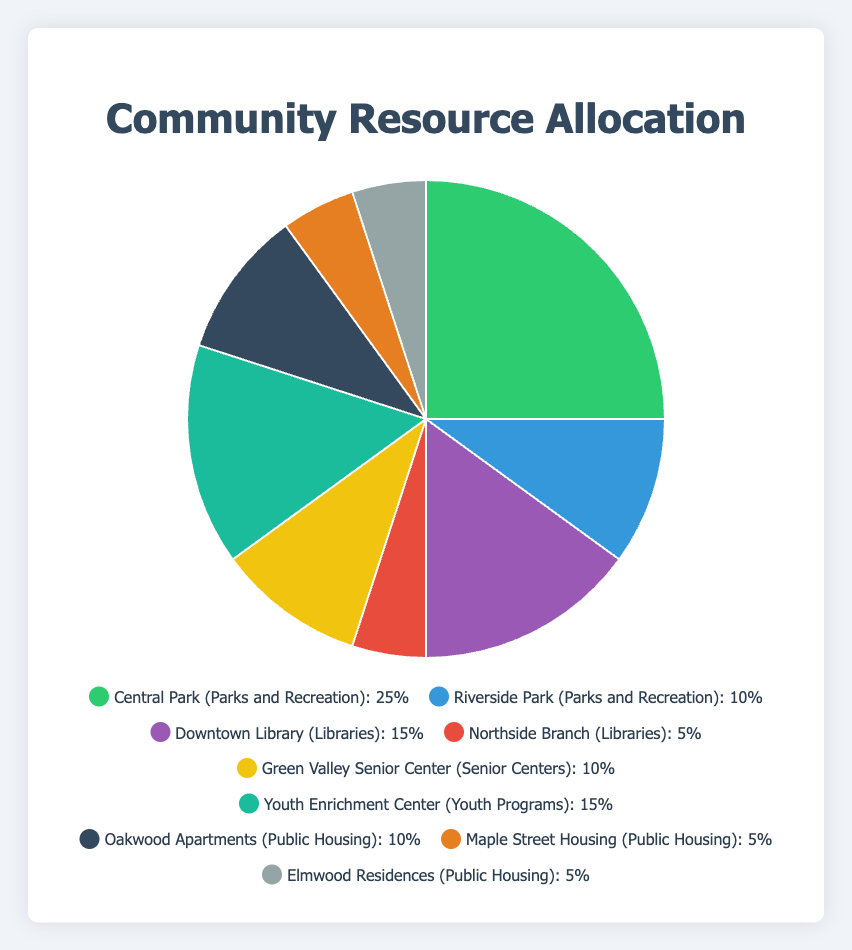What's the total allocation percentage for Public Housing? Sum up the allocation percentages for Oakwood Apartments (10%), Maple Street Housing (5%), and Elmwood Residences (5%). The total allocation percentage for Public Housing is 10% + 5% + 5% = 20%.
Answer: 20% Which entity receives the highest allocation percentage, and what is it? Look at the pie chart and identify the slice with the largest percentage; it's Central Park, with a 25% allocation.
Answer: Central Park, 25% What’s the difference in allocation percentage between Downtown Library and Northside Branch? The allocation percentage for Downtown Library is 15% and for Northside Branch is 5%. The difference is 15% - 5% = 10%.
Answer: 10% How does the allocation for Youth Enrichment Center compare to that of Green Valley Senior Center? Youth Enrichment Center has a 15% allocation and Green Valley Senior Center has a 10% allocation. The Youth Enrichment Center has a 5% higher allocation than the Green Valley Senior Center.
Answer: Youth Enrichment Center has 5% more Which category has a higher combined allocation percentage, Parks and Recreation or Libraries, and by how much? Parks and Recreation has Central Park (25%) and Riverside Park (10%), totaling 35%. Libraries have Downtown Library (15%) and Northside Branch (5%), totaling 20%. Parks and Recreation has 15% more allocation than Libraries.
Answer: Parks and Recreation by 15% What is the average allocation percentage for all entities in Public Housing? Summing the allocation percentages for Oakwood Apartments (10%), Maple Street Housing (5%), and Elmwood Residences (5%) gives 20%. There are 3 entities, so the average is 20% / 3 = 6.67%.
Answer: 6.67% Which entity allocated to Parks and Recreation receives the least percentage, and what is it? Riverside Park in the Parks and Recreation category receives 10%, which is less than Central Park's 25%.
Answer: Riverside Park, 10% What’s the combined allocation percentage for all Senior Centers and Youth Programs? Green Valley Senior Center has 10%, and Youth Enrichment Center has 15%. The combined allocation percentage is 10% + 15% = 25%.
Answer: 25% If another entity was added to Public Housing with a 10% allocation, what would be the new total allocation percentage for Public Housing? Current Public Housing total allocation is 20%. Adding another 10% would give a new total of 20% + 10% = 30%.
Answer: 30% How does the allocation for Riverside Park compare to the combined allocations of Northside Branch and Elmwood Residences? Riverside Park has a 10% allocation. The combined allocation for Northside Branch (5%) and Elmwood Residences (5%) is 5% + 5% = 10%. They are equal.
Answer: Equal 